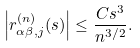Convert formula to latex. <formula><loc_0><loc_0><loc_500><loc_500>\left | r _ { \alpha \beta , j } ^ { ( n ) } ( s ) \right | \leq \frac { C s ^ { 3 } } { n ^ { 3 / 2 } } .</formula> 